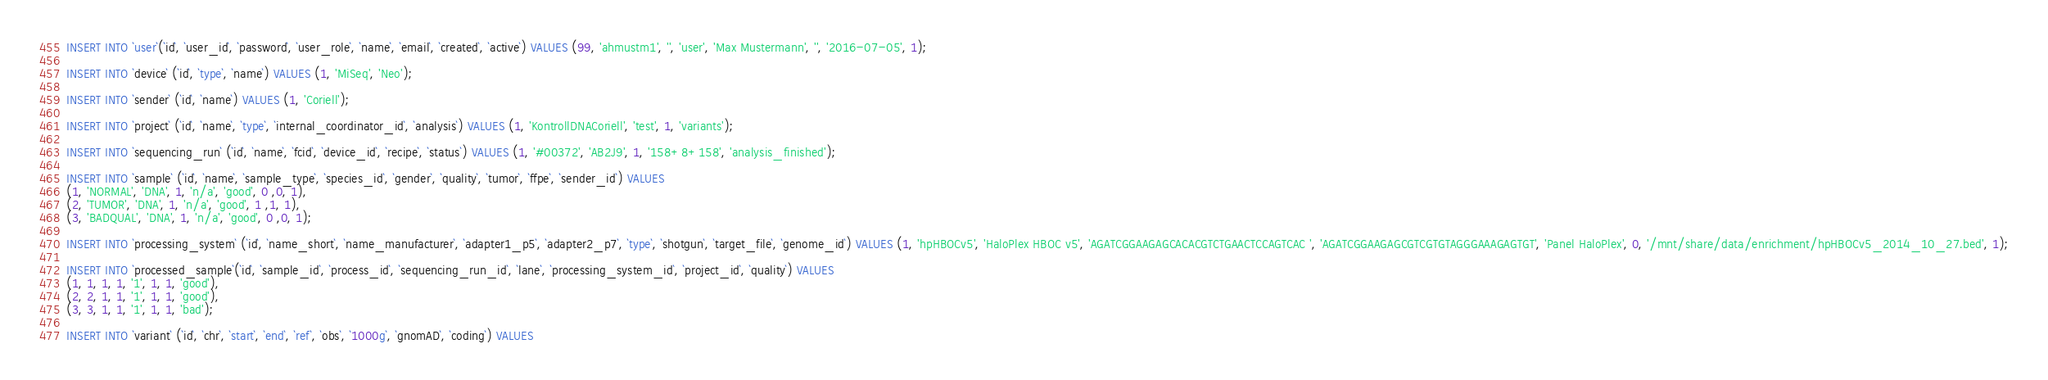Convert code to text. <code><loc_0><loc_0><loc_500><loc_500><_SQL_>
INSERT INTO `user`(`id`, `user_id`, `password`, `user_role`, `name`, `email`, `created`, `active`) VALUES (99, 'ahmustm1', '', 'user', 'Max Mustermann', '', '2016-07-05', 1);

INSERT INTO `device` (`id`, `type`, `name`) VALUES (1, 'MiSeq', 'Neo');

INSERT INTO `sender` (`id`, `name`) VALUES (1, 'Coriell');

INSERT INTO `project` (`id`, `name`, `type`, `internal_coordinator_id`, `analysis`) VALUES (1, 'KontrollDNACoriell', 'test', 1, 'variants');

INSERT INTO `sequencing_run` (`id`, `name`, `fcid`, `device_id`, `recipe`, `status`) VALUES (1, '#00372', 'AB2J9', 1, '158+8+158', 'analysis_finished');

INSERT INTO `sample` (`id`, `name`, `sample_type`, `species_id`, `gender`, `quality`, `tumor`, `ffpe`, `sender_id`) VALUES 
(1, 'NORMAL', 'DNA', 1, 'n/a', 'good', 0 ,0, 1),
(2, 'TUMOR', 'DNA', 1, 'n/a', 'good', 1 ,1, 1),
(3, 'BADQUAL', 'DNA', 1, 'n/a', 'good', 0 ,0, 1);

INSERT INTO `processing_system` (`id`, `name_short`, `name_manufacturer`, `adapter1_p5`, `adapter2_p7`, `type`, `shotgun`, `target_file`, `genome_id`) VALUES (1, 'hpHBOCv5', 'HaloPlex HBOC v5', 'AGATCGGAAGAGCACACGTCTGAACTCCAGTCAC ', 'AGATCGGAAGAGCGTCGTGTAGGGAAAGAGTGT', 'Panel HaloPlex', 0, '/mnt/share/data/enrichment/hpHBOCv5_2014_10_27.bed', 1);

INSERT INTO `processed_sample`(`id`, `sample_id`, `process_id`, `sequencing_run_id`, `lane`, `processing_system_id`, `project_id`, `quality`) VALUES 
(1, 1, 1, 1, '1', 1, 1, 'good'),
(2, 2, 1, 1, '1', 1, 1, 'good'),
(3, 3, 1, 1, '1', 1, 1, 'bad');

INSERT INTO `variant` (`id`, `chr`, `start`, `end`, `ref`, `obs`, `1000g`, `gnomAD`, `coding`) VALUES</code> 